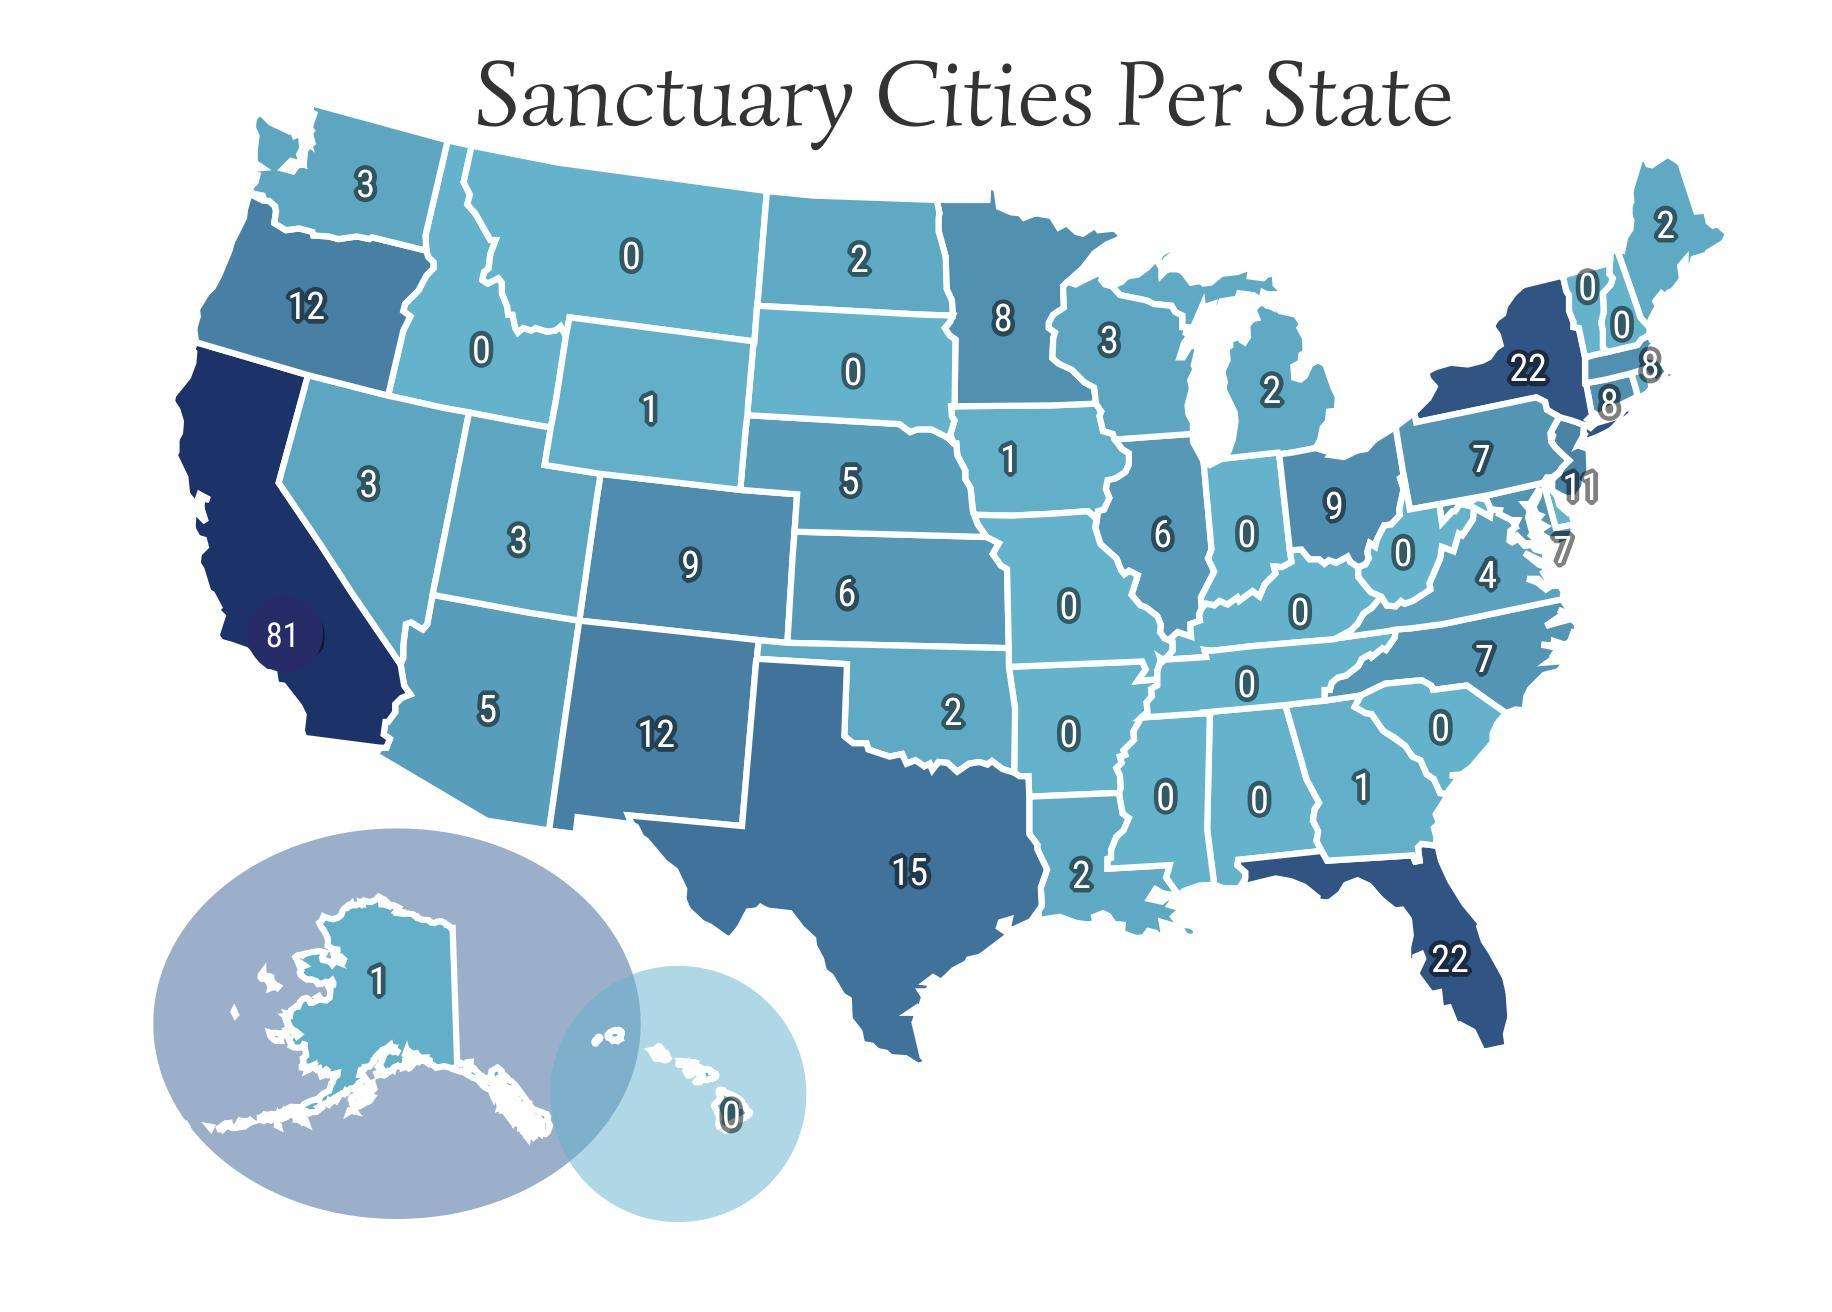What is the second highest number of sanctuary cities per state?
Answer the question with a short phrase. 22 What is the third highest number of sanctuary cities per state? 15 What is the second lowest number of sanctuary cities per state? 1 How many states have more than 10 sanctuary cities? 7 How many states have more than 20 sanctuary cities? 3 How many states have the second highest number of sanctuary cities? 2 